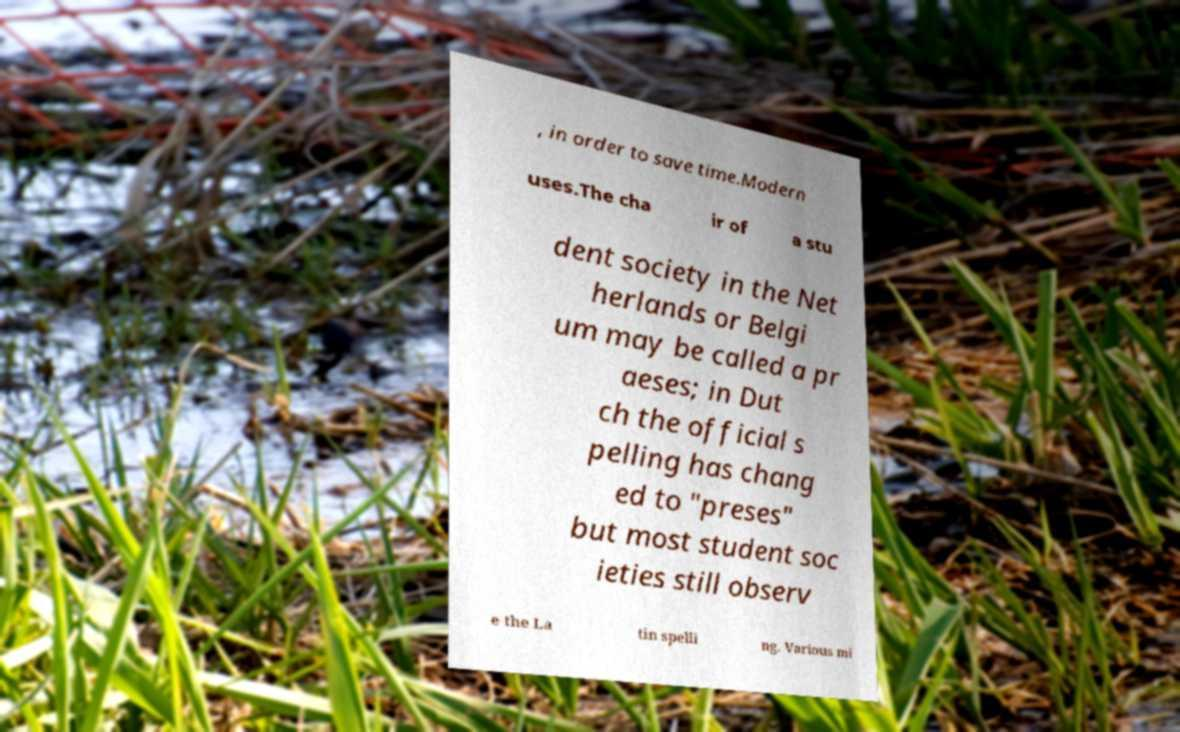I need the written content from this picture converted into text. Can you do that? , in order to save time.Modern uses.The cha ir of a stu dent society in the Net herlands or Belgi um may be called a pr aeses; in Dut ch the official s pelling has chang ed to "preses" but most student soc ieties still observ e the La tin spelli ng. Various mi 